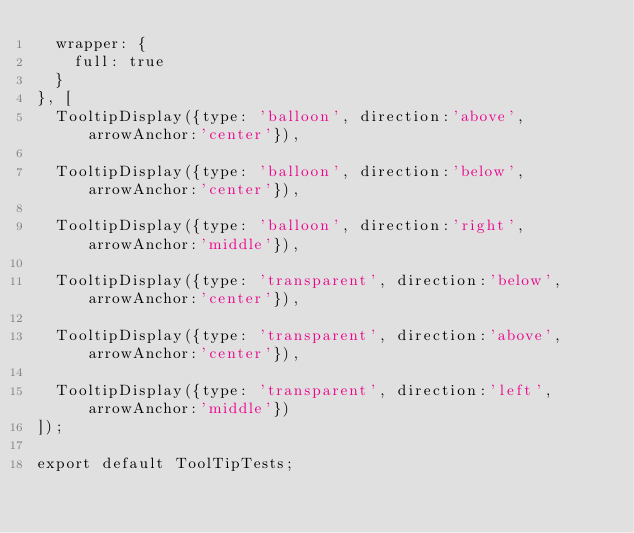<code> <loc_0><loc_0><loc_500><loc_500><_JavaScript_>	wrapper: {
		full: true
	}
}, [
	TooltipDisplay({type: 'balloon', direction:'above', arrowAnchor:'center'}),

	TooltipDisplay({type: 'balloon', direction:'below', arrowAnchor:'center'}),

	TooltipDisplay({type: 'balloon', direction:'right', arrowAnchor:'middle'}),

	TooltipDisplay({type: 'transparent', direction:'below', arrowAnchor:'center'}),

	TooltipDisplay({type: 'transparent', direction:'above', arrowAnchor:'center'}),

	TooltipDisplay({type: 'transparent', direction:'left', arrowAnchor:'middle'})
]);

export default ToolTipTests;
</code> 